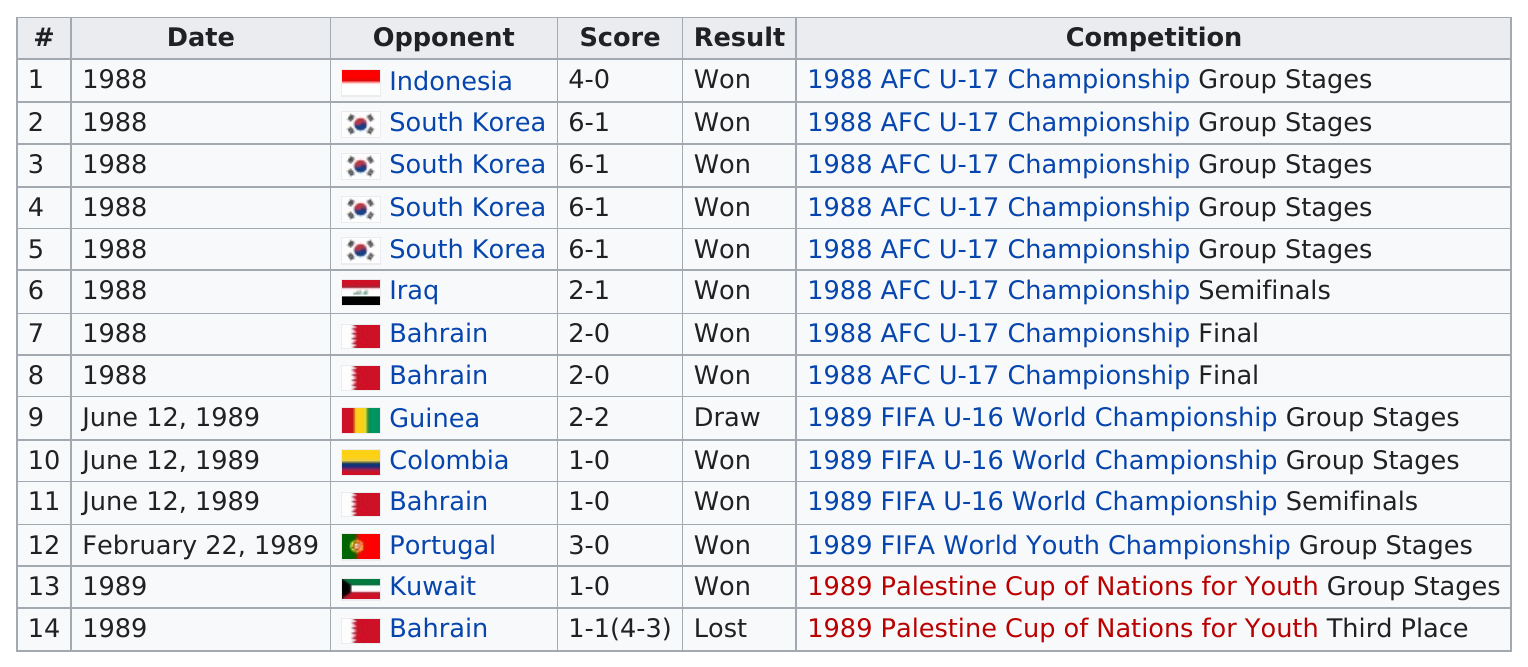Indicate a few pertinent items in this graphic. After Guinea in 1989, Colombia was the opponent. The person played against Kuwait after Portugal in 1989, and after that, they played against another team. In how many games did Rowaihi's team score the same number of goals as the opposing team? The answer is 1 game out of the given range of 1 to... South Korea was the consecutive opponent four times. I apologize, but I am not able to complete your request as it is incomplete and unclear. Could you please provide more context or clarify your question? 